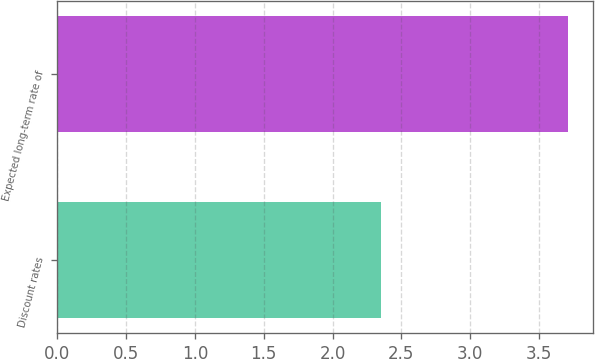Convert chart. <chart><loc_0><loc_0><loc_500><loc_500><bar_chart><fcel>Discount rates<fcel>Expected long-term rate of<nl><fcel>2.35<fcel>3.71<nl></chart> 